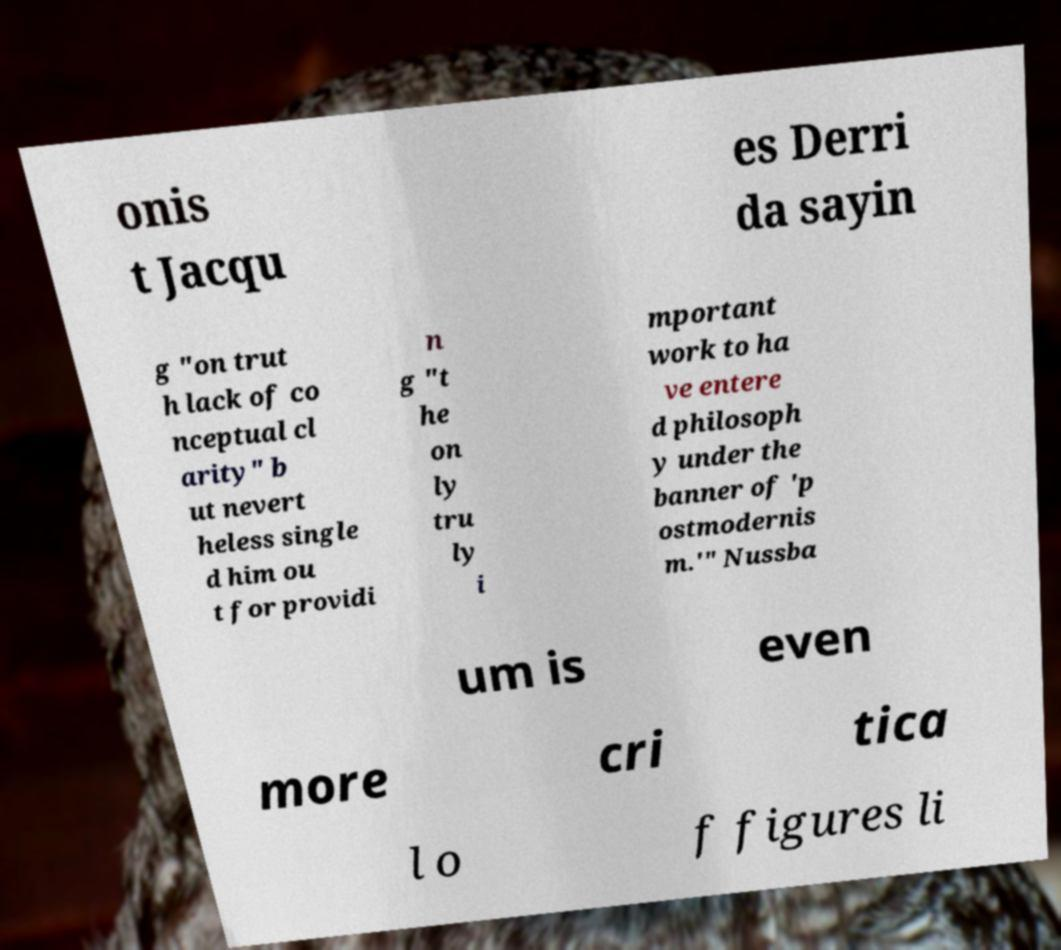I need the written content from this picture converted into text. Can you do that? onis t Jacqu es Derri da sayin g "on trut h lack of co nceptual cl arity" b ut nevert heless single d him ou t for providi n g "t he on ly tru ly i mportant work to ha ve entere d philosoph y under the banner of 'p ostmodernis m.'" Nussba um is even more cri tica l o f figures li 